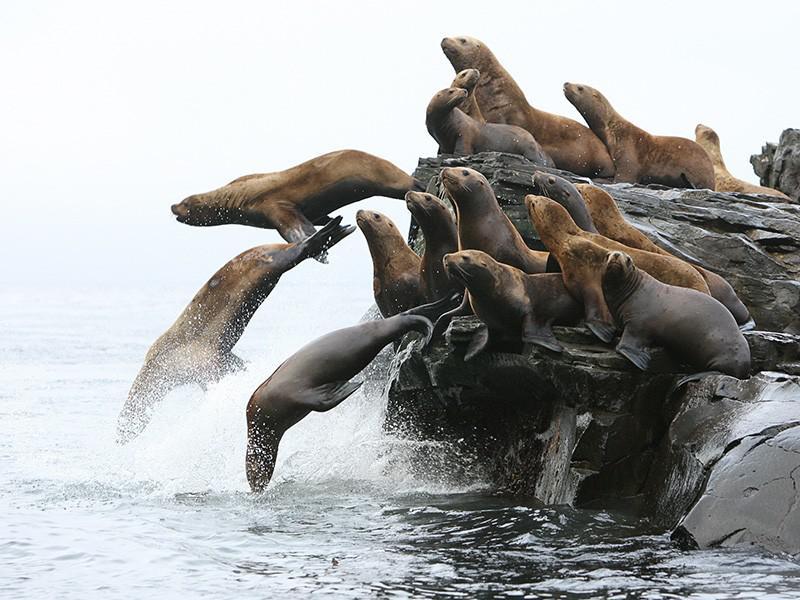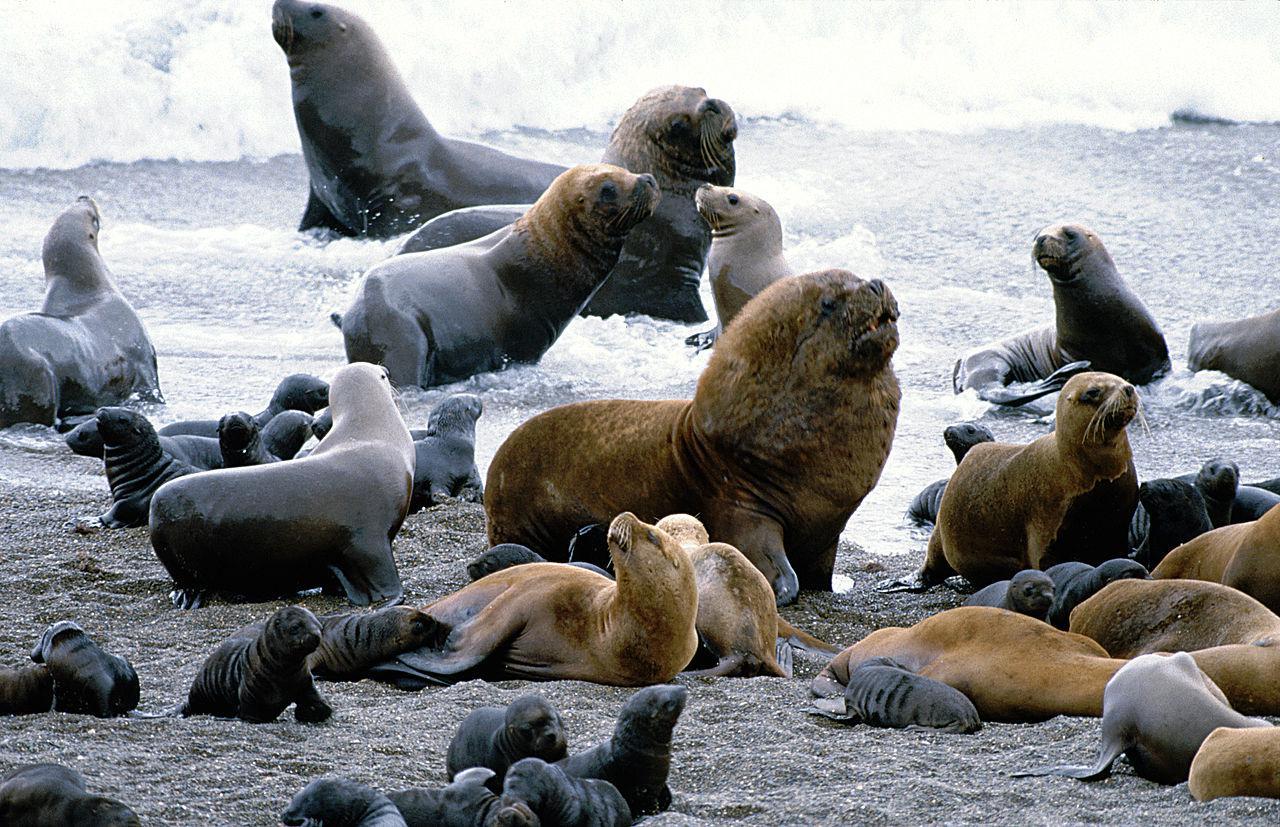The first image is the image on the left, the second image is the image on the right. Evaluate the accuracy of this statement regarding the images: "Each image includes no more than two larger seals with raised head and shoulders surrounded by smaller seals.". Is it true? Answer yes or no. No. The first image is the image on the left, the second image is the image on the right. Assess this claim about the two images: "One of the images features only two seals.". Correct or not? Answer yes or no. No. 